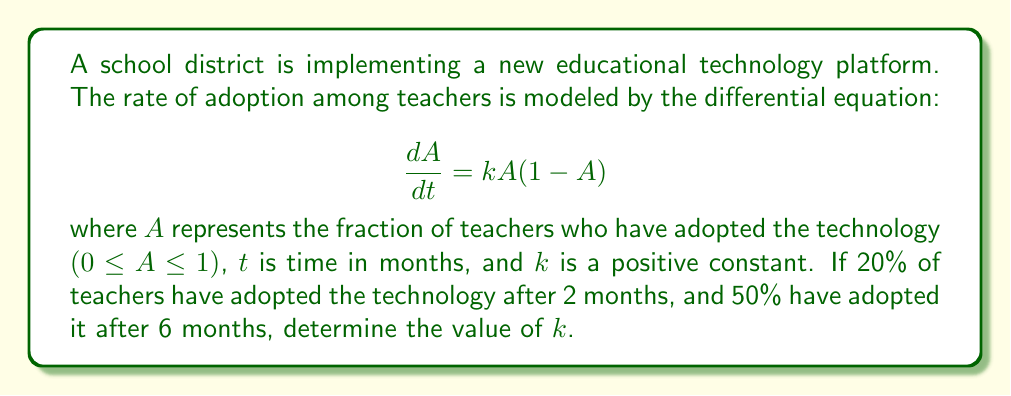What is the answer to this math problem? To solve this problem, we'll follow these steps:

1) The given differential equation is a logistic growth model. Its solution is:

   $$A(t) = \frac{A_0e^{kt}}{1-A_0+A_0e^{kt}}$$

   where $A_0$ is the initial adoption rate at $t=0$.

2) We're given two data points:
   At $t=2$ months, $A=0.2$
   At $t=6$ months, $A=0.5$

3) Let's use the first data point to find $A_0$:

   $$0.2 = \frac{A_0e^{2k}}{1-A_0+A_0e^{2k}}$$

4) Solving this for $A_0$:

   $$A_0 = \frac{0.2}{e^{2k}-0.8}$$

5) Now, let's use the second data point:

   $$0.5 = \frac{A_0e^{6k}}{1-A_0+A_0e^{6k}}$$

6) Substituting the expression for $A_0$ from step 4:

   $$0.5 = \frac{\frac{0.2}{e^{2k}-0.8}e^{6k}}{1-\frac{0.2}{e^{2k}-0.8}+\frac{0.2}{e^{2k}-0.8}e^{6k}}$$

7) Simplifying:

   $$0.5 = \frac{0.2e^{4k}}{e^{2k}-0.8+0.2e^{4k}}$$

8) Solving this equation for $k$:

   $$e^{2k} = 3$$

9) Taking the natural logarithm of both sides:

   $$2k = \ln(3)$$

10) Solving for $k$:

    $$k = \frac{\ln(3)}{2} \approx 0.5493$$
Answer: $k = \frac{\ln(3)}{2} \approx 0.5493$ month^(-1) 